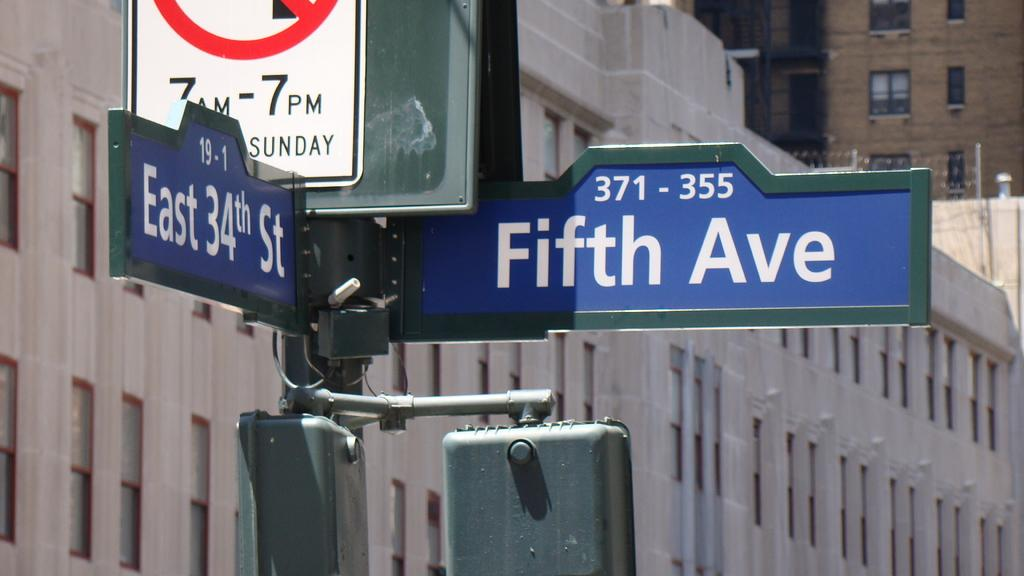<image>
Render a clear and concise summary of the photo. An intersection with east 34th and fifth avenue on them. 